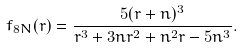<formula> <loc_0><loc_0><loc_500><loc_500>f _ { 8 N } ( r ) = \frac { 5 ( r + n ) ^ { 3 } } { r ^ { 3 } + 3 n r ^ { 2 } + n ^ { 2 } r - 5 n ^ { 3 } } .</formula> 